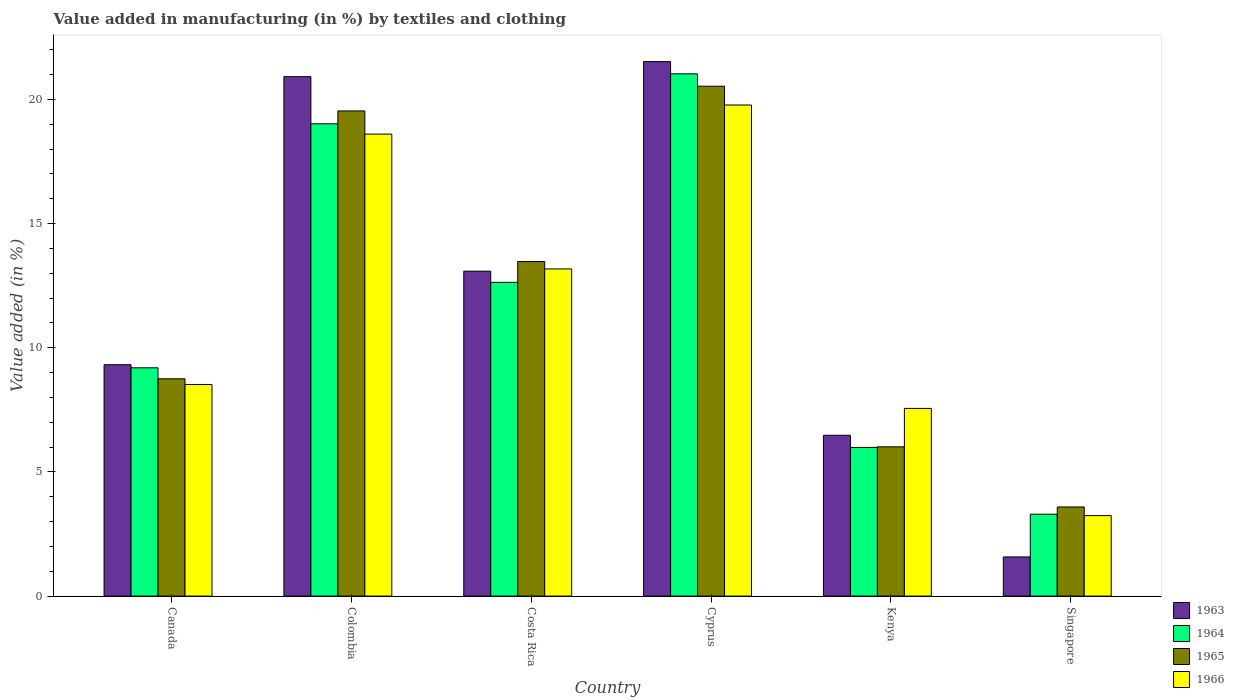Are the number of bars per tick equal to the number of legend labels?
Provide a short and direct response. Yes. How many bars are there on the 1st tick from the left?
Make the answer very short. 4. How many bars are there on the 3rd tick from the right?
Your answer should be compact. 4. What is the label of the 1st group of bars from the left?
Make the answer very short. Canada. What is the percentage of value added in manufacturing by textiles and clothing in 1965 in Singapore?
Your answer should be very brief. 3.59. Across all countries, what is the maximum percentage of value added in manufacturing by textiles and clothing in 1965?
Offer a terse response. 20.53. Across all countries, what is the minimum percentage of value added in manufacturing by textiles and clothing in 1966?
Offer a very short reply. 3.24. In which country was the percentage of value added in manufacturing by textiles and clothing in 1965 maximum?
Provide a succinct answer. Cyprus. In which country was the percentage of value added in manufacturing by textiles and clothing in 1963 minimum?
Your answer should be compact. Singapore. What is the total percentage of value added in manufacturing by textiles and clothing in 1966 in the graph?
Give a very brief answer. 70.87. What is the difference between the percentage of value added in manufacturing by textiles and clothing in 1966 in Costa Rica and that in Singapore?
Provide a succinct answer. 9.93. What is the difference between the percentage of value added in manufacturing by textiles and clothing in 1966 in Kenya and the percentage of value added in manufacturing by textiles and clothing in 1965 in Costa Rica?
Make the answer very short. -5.91. What is the average percentage of value added in manufacturing by textiles and clothing in 1963 per country?
Ensure brevity in your answer.  12.15. What is the difference between the percentage of value added in manufacturing by textiles and clothing of/in 1966 and percentage of value added in manufacturing by textiles and clothing of/in 1963 in Colombia?
Your answer should be compact. -2.31. In how many countries, is the percentage of value added in manufacturing by textiles and clothing in 1964 greater than 13 %?
Ensure brevity in your answer.  2. What is the ratio of the percentage of value added in manufacturing by textiles and clothing in 1964 in Colombia to that in Cyprus?
Offer a very short reply. 0.9. Is the difference between the percentage of value added in manufacturing by textiles and clothing in 1966 in Cyprus and Singapore greater than the difference between the percentage of value added in manufacturing by textiles and clothing in 1963 in Cyprus and Singapore?
Ensure brevity in your answer.  No. What is the difference between the highest and the second highest percentage of value added in manufacturing by textiles and clothing in 1965?
Keep it short and to the point. -0.99. What is the difference between the highest and the lowest percentage of value added in manufacturing by textiles and clothing in 1964?
Your response must be concise. 17.73. In how many countries, is the percentage of value added in manufacturing by textiles and clothing in 1965 greater than the average percentage of value added in manufacturing by textiles and clothing in 1965 taken over all countries?
Ensure brevity in your answer.  3. What does the 4th bar from the left in Canada represents?
Provide a succinct answer. 1966. What does the 3rd bar from the right in Kenya represents?
Ensure brevity in your answer.  1964. Are all the bars in the graph horizontal?
Your answer should be compact. No. What is the difference between two consecutive major ticks on the Y-axis?
Provide a short and direct response. 5. How many legend labels are there?
Your answer should be compact. 4. What is the title of the graph?
Your response must be concise. Value added in manufacturing (in %) by textiles and clothing. Does "1985" appear as one of the legend labels in the graph?
Offer a terse response. No. What is the label or title of the X-axis?
Keep it short and to the point. Country. What is the label or title of the Y-axis?
Offer a very short reply. Value added (in %). What is the Value added (in %) of 1963 in Canada?
Your answer should be very brief. 9.32. What is the Value added (in %) in 1964 in Canada?
Your answer should be very brief. 9.19. What is the Value added (in %) of 1965 in Canada?
Offer a very short reply. 8.75. What is the Value added (in %) of 1966 in Canada?
Provide a succinct answer. 8.52. What is the Value added (in %) in 1963 in Colombia?
Offer a terse response. 20.92. What is the Value added (in %) of 1964 in Colombia?
Ensure brevity in your answer.  19.02. What is the Value added (in %) of 1965 in Colombia?
Keep it short and to the point. 19.54. What is the Value added (in %) of 1966 in Colombia?
Ensure brevity in your answer.  18.6. What is the Value added (in %) of 1963 in Costa Rica?
Offer a very short reply. 13.08. What is the Value added (in %) of 1964 in Costa Rica?
Keep it short and to the point. 12.63. What is the Value added (in %) in 1965 in Costa Rica?
Your answer should be very brief. 13.47. What is the Value added (in %) of 1966 in Costa Rica?
Provide a succinct answer. 13.17. What is the Value added (in %) of 1963 in Cyprus?
Offer a very short reply. 21.52. What is the Value added (in %) of 1964 in Cyprus?
Your answer should be very brief. 21.03. What is the Value added (in %) in 1965 in Cyprus?
Offer a very short reply. 20.53. What is the Value added (in %) of 1966 in Cyprus?
Offer a terse response. 19.78. What is the Value added (in %) of 1963 in Kenya?
Keep it short and to the point. 6.48. What is the Value added (in %) in 1964 in Kenya?
Provide a succinct answer. 5.99. What is the Value added (in %) of 1965 in Kenya?
Your answer should be very brief. 6.01. What is the Value added (in %) in 1966 in Kenya?
Provide a short and direct response. 7.56. What is the Value added (in %) in 1963 in Singapore?
Your answer should be compact. 1.58. What is the Value added (in %) in 1964 in Singapore?
Your answer should be compact. 3.3. What is the Value added (in %) of 1965 in Singapore?
Your answer should be compact. 3.59. What is the Value added (in %) in 1966 in Singapore?
Keep it short and to the point. 3.24. Across all countries, what is the maximum Value added (in %) of 1963?
Keep it short and to the point. 21.52. Across all countries, what is the maximum Value added (in %) in 1964?
Give a very brief answer. 21.03. Across all countries, what is the maximum Value added (in %) in 1965?
Offer a terse response. 20.53. Across all countries, what is the maximum Value added (in %) in 1966?
Keep it short and to the point. 19.78. Across all countries, what is the minimum Value added (in %) in 1963?
Give a very brief answer. 1.58. Across all countries, what is the minimum Value added (in %) of 1964?
Your answer should be very brief. 3.3. Across all countries, what is the minimum Value added (in %) of 1965?
Offer a terse response. 3.59. Across all countries, what is the minimum Value added (in %) in 1966?
Offer a terse response. 3.24. What is the total Value added (in %) in 1963 in the graph?
Make the answer very short. 72.9. What is the total Value added (in %) in 1964 in the graph?
Offer a terse response. 71.16. What is the total Value added (in %) in 1965 in the graph?
Provide a short and direct response. 71.89. What is the total Value added (in %) in 1966 in the graph?
Your response must be concise. 70.87. What is the difference between the Value added (in %) in 1963 in Canada and that in Colombia?
Offer a terse response. -11.6. What is the difference between the Value added (in %) of 1964 in Canada and that in Colombia?
Offer a terse response. -9.82. What is the difference between the Value added (in %) of 1965 in Canada and that in Colombia?
Give a very brief answer. -10.79. What is the difference between the Value added (in %) in 1966 in Canada and that in Colombia?
Ensure brevity in your answer.  -10.08. What is the difference between the Value added (in %) of 1963 in Canada and that in Costa Rica?
Your answer should be very brief. -3.77. What is the difference between the Value added (in %) in 1964 in Canada and that in Costa Rica?
Keep it short and to the point. -3.44. What is the difference between the Value added (in %) of 1965 in Canada and that in Costa Rica?
Keep it short and to the point. -4.72. What is the difference between the Value added (in %) in 1966 in Canada and that in Costa Rica?
Offer a very short reply. -4.65. What is the difference between the Value added (in %) in 1963 in Canada and that in Cyprus?
Keep it short and to the point. -12.21. What is the difference between the Value added (in %) of 1964 in Canada and that in Cyprus?
Provide a succinct answer. -11.84. What is the difference between the Value added (in %) in 1965 in Canada and that in Cyprus?
Your answer should be very brief. -11.78. What is the difference between the Value added (in %) of 1966 in Canada and that in Cyprus?
Ensure brevity in your answer.  -11.25. What is the difference between the Value added (in %) of 1963 in Canada and that in Kenya?
Make the answer very short. 2.84. What is the difference between the Value added (in %) in 1964 in Canada and that in Kenya?
Offer a terse response. 3.21. What is the difference between the Value added (in %) in 1965 in Canada and that in Kenya?
Give a very brief answer. 2.74. What is the difference between the Value added (in %) in 1966 in Canada and that in Kenya?
Your answer should be compact. 0.96. What is the difference between the Value added (in %) of 1963 in Canada and that in Singapore?
Give a very brief answer. 7.74. What is the difference between the Value added (in %) of 1964 in Canada and that in Singapore?
Offer a terse response. 5.9. What is the difference between the Value added (in %) of 1965 in Canada and that in Singapore?
Your response must be concise. 5.16. What is the difference between the Value added (in %) of 1966 in Canada and that in Singapore?
Your answer should be compact. 5.28. What is the difference between the Value added (in %) in 1963 in Colombia and that in Costa Rica?
Provide a short and direct response. 7.83. What is the difference between the Value added (in %) of 1964 in Colombia and that in Costa Rica?
Keep it short and to the point. 6.38. What is the difference between the Value added (in %) in 1965 in Colombia and that in Costa Rica?
Offer a very short reply. 6.06. What is the difference between the Value added (in %) of 1966 in Colombia and that in Costa Rica?
Provide a succinct answer. 5.43. What is the difference between the Value added (in %) of 1963 in Colombia and that in Cyprus?
Your response must be concise. -0.61. What is the difference between the Value added (in %) in 1964 in Colombia and that in Cyprus?
Give a very brief answer. -2.01. What is the difference between the Value added (in %) of 1965 in Colombia and that in Cyprus?
Your response must be concise. -0.99. What is the difference between the Value added (in %) in 1966 in Colombia and that in Cyprus?
Offer a terse response. -1.17. What is the difference between the Value added (in %) of 1963 in Colombia and that in Kenya?
Offer a very short reply. 14.44. What is the difference between the Value added (in %) in 1964 in Colombia and that in Kenya?
Offer a terse response. 13.03. What is the difference between the Value added (in %) in 1965 in Colombia and that in Kenya?
Give a very brief answer. 13.53. What is the difference between the Value added (in %) of 1966 in Colombia and that in Kenya?
Offer a terse response. 11.05. What is the difference between the Value added (in %) of 1963 in Colombia and that in Singapore?
Your answer should be compact. 19.34. What is the difference between the Value added (in %) in 1964 in Colombia and that in Singapore?
Your answer should be very brief. 15.72. What is the difference between the Value added (in %) in 1965 in Colombia and that in Singapore?
Your answer should be compact. 15.95. What is the difference between the Value added (in %) of 1966 in Colombia and that in Singapore?
Give a very brief answer. 15.36. What is the difference between the Value added (in %) in 1963 in Costa Rica and that in Cyprus?
Provide a succinct answer. -8.44. What is the difference between the Value added (in %) in 1964 in Costa Rica and that in Cyprus?
Offer a very short reply. -8.4. What is the difference between the Value added (in %) of 1965 in Costa Rica and that in Cyprus?
Your answer should be very brief. -7.06. What is the difference between the Value added (in %) in 1966 in Costa Rica and that in Cyprus?
Ensure brevity in your answer.  -6.6. What is the difference between the Value added (in %) in 1963 in Costa Rica and that in Kenya?
Provide a short and direct response. 6.61. What is the difference between the Value added (in %) in 1964 in Costa Rica and that in Kenya?
Your answer should be compact. 6.65. What is the difference between the Value added (in %) of 1965 in Costa Rica and that in Kenya?
Offer a terse response. 7.46. What is the difference between the Value added (in %) of 1966 in Costa Rica and that in Kenya?
Keep it short and to the point. 5.62. What is the difference between the Value added (in %) of 1963 in Costa Rica and that in Singapore?
Provide a succinct answer. 11.51. What is the difference between the Value added (in %) in 1964 in Costa Rica and that in Singapore?
Your answer should be very brief. 9.34. What is the difference between the Value added (in %) of 1965 in Costa Rica and that in Singapore?
Keep it short and to the point. 9.88. What is the difference between the Value added (in %) in 1966 in Costa Rica and that in Singapore?
Provide a short and direct response. 9.93. What is the difference between the Value added (in %) of 1963 in Cyprus and that in Kenya?
Provide a short and direct response. 15.05. What is the difference between the Value added (in %) of 1964 in Cyprus and that in Kenya?
Offer a very short reply. 15.04. What is the difference between the Value added (in %) in 1965 in Cyprus and that in Kenya?
Ensure brevity in your answer.  14.52. What is the difference between the Value added (in %) in 1966 in Cyprus and that in Kenya?
Your answer should be very brief. 12.22. What is the difference between the Value added (in %) of 1963 in Cyprus and that in Singapore?
Ensure brevity in your answer.  19.95. What is the difference between the Value added (in %) of 1964 in Cyprus and that in Singapore?
Keep it short and to the point. 17.73. What is the difference between the Value added (in %) of 1965 in Cyprus and that in Singapore?
Your answer should be very brief. 16.94. What is the difference between the Value added (in %) in 1966 in Cyprus and that in Singapore?
Your answer should be very brief. 16.53. What is the difference between the Value added (in %) of 1963 in Kenya and that in Singapore?
Your answer should be very brief. 4.9. What is the difference between the Value added (in %) of 1964 in Kenya and that in Singapore?
Keep it short and to the point. 2.69. What is the difference between the Value added (in %) in 1965 in Kenya and that in Singapore?
Offer a terse response. 2.42. What is the difference between the Value added (in %) in 1966 in Kenya and that in Singapore?
Ensure brevity in your answer.  4.32. What is the difference between the Value added (in %) in 1963 in Canada and the Value added (in %) in 1964 in Colombia?
Keep it short and to the point. -9.7. What is the difference between the Value added (in %) in 1963 in Canada and the Value added (in %) in 1965 in Colombia?
Provide a succinct answer. -10.22. What is the difference between the Value added (in %) of 1963 in Canada and the Value added (in %) of 1966 in Colombia?
Offer a terse response. -9.29. What is the difference between the Value added (in %) in 1964 in Canada and the Value added (in %) in 1965 in Colombia?
Keep it short and to the point. -10.34. What is the difference between the Value added (in %) of 1964 in Canada and the Value added (in %) of 1966 in Colombia?
Keep it short and to the point. -9.41. What is the difference between the Value added (in %) in 1965 in Canada and the Value added (in %) in 1966 in Colombia?
Keep it short and to the point. -9.85. What is the difference between the Value added (in %) in 1963 in Canada and the Value added (in %) in 1964 in Costa Rica?
Your response must be concise. -3.32. What is the difference between the Value added (in %) of 1963 in Canada and the Value added (in %) of 1965 in Costa Rica?
Offer a very short reply. -4.16. What is the difference between the Value added (in %) in 1963 in Canada and the Value added (in %) in 1966 in Costa Rica?
Provide a short and direct response. -3.86. What is the difference between the Value added (in %) of 1964 in Canada and the Value added (in %) of 1965 in Costa Rica?
Provide a short and direct response. -4.28. What is the difference between the Value added (in %) of 1964 in Canada and the Value added (in %) of 1966 in Costa Rica?
Make the answer very short. -3.98. What is the difference between the Value added (in %) of 1965 in Canada and the Value added (in %) of 1966 in Costa Rica?
Your answer should be very brief. -4.42. What is the difference between the Value added (in %) in 1963 in Canada and the Value added (in %) in 1964 in Cyprus?
Offer a terse response. -11.71. What is the difference between the Value added (in %) of 1963 in Canada and the Value added (in %) of 1965 in Cyprus?
Your answer should be compact. -11.21. What is the difference between the Value added (in %) in 1963 in Canada and the Value added (in %) in 1966 in Cyprus?
Your answer should be very brief. -10.46. What is the difference between the Value added (in %) in 1964 in Canada and the Value added (in %) in 1965 in Cyprus?
Make the answer very short. -11.34. What is the difference between the Value added (in %) in 1964 in Canada and the Value added (in %) in 1966 in Cyprus?
Offer a very short reply. -10.58. What is the difference between the Value added (in %) of 1965 in Canada and the Value added (in %) of 1966 in Cyprus?
Provide a short and direct response. -11.02. What is the difference between the Value added (in %) of 1963 in Canada and the Value added (in %) of 1964 in Kenya?
Keep it short and to the point. 3.33. What is the difference between the Value added (in %) of 1963 in Canada and the Value added (in %) of 1965 in Kenya?
Keep it short and to the point. 3.31. What is the difference between the Value added (in %) of 1963 in Canada and the Value added (in %) of 1966 in Kenya?
Keep it short and to the point. 1.76. What is the difference between the Value added (in %) of 1964 in Canada and the Value added (in %) of 1965 in Kenya?
Your answer should be very brief. 3.18. What is the difference between the Value added (in %) in 1964 in Canada and the Value added (in %) in 1966 in Kenya?
Your response must be concise. 1.64. What is the difference between the Value added (in %) of 1965 in Canada and the Value added (in %) of 1966 in Kenya?
Your answer should be very brief. 1.19. What is the difference between the Value added (in %) of 1963 in Canada and the Value added (in %) of 1964 in Singapore?
Your response must be concise. 6.02. What is the difference between the Value added (in %) in 1963 in Canada and the Value added (in %) in 1965 in Singapore?
Make the answer very short. 5.73. What is the difference between the Value added (in %) of 1963 in Canada and the Value added (in %) of 1966 in Singapore?
Your answer should be very brief. 6.08. What is the difference between the Value added (in %) in 1964 in Canada and the Value added (in %) in 1965 in Singapore?
Your answer should be very brief. 5.6. What is the difference between the Value added (in %) in 1964 in Canada and the Value added (in %) in 1966 in Singapore?
Give a very brief answer. 5.95. What is the difference between the Value added (in %) in 1965 in Canada and the Value added (in %) in 1966 in Singapore?
Make the answer very short. 5.51. What is the difference between the Value added (in %) of 1963 in Colombia and the Value added (in %) of 1964 in Costa Rica?
Your response must be concise. 8.28. What is the difference between the Value added (in %) in 1963 in Colombia and the Value added (in %) in 1965 in Costa Rica?
Give a very brief answer. 7.44. What is the difference between the Value added (in %) in 1963 in Colombia and the Value added (in %) in 1966 in Costa Rica?
Offer a terse response. 7.74. What is the difference between the Value added (in %) of 1964 in Colombia and the Value added (in %) of 1965 in Costa Rica?
Offer a very short reply. 5.55. What is the difference between the Value added (in %) in 1964 in Colombia and the Value added (in %) in 1966 in Costa Rica?
Provide a succinct answer. 5.84. What is the difference between the Value added (in %) of 1965 in Colombia and the Value added (in %) of 1966 in Costa Rica?
Your answer should be very brief. 6.36. What is the difference between the Value added (in %) in 1963 in Colombia and the Value added (in %) in 1964 in Cyprus?
Your response must be concise. -0.11. What is the difference between the Value added (in %) in 1963 in Colombia and the Value added (in %) in 1965 in Cyprus?
Give a very brief answer. 0.39. What is the difference between the Value added (in %) in 1963 in Colombia and the Value added (in %) in 1966 in Cyprus?
Provide a short and direct response. 1.14. What is the difference between the Value added (in %) in 1964 in Colombia and the Value added (in %) in 1965 in Cyprus?
Your answer should be compact. -1.51. What is the difference between the Value added (in %) of 1964 in Colombia and the Value added (in %) of 1966 in Cyprus?
Your response must be concise. -0.76. What is the difference between the Value added (in %) of 1965 in Colombia and the Value added (in %) of 1966 in Cyprus?
Your answer should be compact. -0.24. What is the difference between the Value added (in %) in 1963 in Colombia and the Value added (in %) in 1964 in Kenya?
Ensure brevity in your answer.  14.93. What is the difference between the Value added (in %) of 1963 in Colombia and the Value added (in %) of 1965 in Kenya?
Offer a terse response. 14.91. What is the difference between the Value added (in %) in 1963 in Colombia and the Value added (in %) in 1966 in Kenya?
Ensure brevity in your answer.  13.36. What is the difference between the Value added (in %) of 1964 in Colombia and the Value added (in %) of 1965 in Kenya?
Ensure brevity in your answer.  13.01. What is the difference between the Value added (in %) of 1964 in Colombia and the Value added (in %) of 1966 in Kenya?
Your answer should be very brief. 11.46. What is the difference between the Value added (in %) in 1965 in Colombia and the Value added (in %) in 1966 in Kenya?
Provide a succinct answer. 11.98. What is the difference between the Value added (in %) of 1963 in Colombia and the Value added (in %) of 1964 in Singapore?
Make the answer very short. 17.62. What is the difference between the Value added (in %) in 1963 in Colombia and the Value added (in %) in 1965 in Singapore?
Ensure brevity in your answer.  17.33. What is the difference between the Value added (in %) of 1963 in Colombia and the Value added (in %) of 1966 in Singapore?
Provide a succinct answer. 17.68. What is the difference between the Value added (in %) in 1964 in Colombia and the Value added (in %) in 1965 in Singapore?
Provide a succinct answer. 15.43. What is the difference between the Value added (in %) in 1964 in Colombia and the Value added (in %) in 1966 in Singapore?
Offer a very short reply. 15.78. What is the difference between the Value added (in %) of 1965 in Colombia and the Value added (in %) of 1966 in Singapore?
Give a very brief answer. 16.3. What is the difference between the Value added (in %) of 1963 in Costa Rica and the Value added (in %) of 1964 in Cyprus?
Your response must be concise. -7.95. What is the difference between the Value added (in %) of 1963 in Costa Rica and the Value added (in %) of 1965 in Cyprus?
Offer a very short reply. -7.45. What is the difference between the Value added (in %) in 1963 in Costa Rica and the Value added (in %) in 1966 in Cyprus?
Your answer should be very brief. -6.69. What is the difference between the Value added (in %) in 1964 in Costa Rica and the Value added (in %) in 1965 in Cyprus?
Offer a very short reply. -7.9. What is the difference between the Value added (in %) in 1964 in Costa Rica and the Value added (in %) in 1966 in Cyprus?
Keep it short and to the point. -7.14. What is the difference between the Value added (in %) of 1965 in Costa Rica and the Value added (in %) of 1966 in Cyprus?
Give a very brief answer. -6.3. What is the difference between the Value added (in %) of 1963 in Costa Rica and the Value added (in %) of 1964 in Kenya?
Ensure brevity in your answer.  7.1. What is the difference between the Value added (in %) of 1963 in Costa Rica and the Value added (in %) of 1965 in Kenya?
Offer a terse response. 7.07. What is the difference between the Value added (in %) in 1963 in Costa Rica and the Value added (in %) in 1966 in Kenya?
Make the answer very short. 5.53. What is the difference between the Value added (in %) of 1964 in Costa Rica and the Value added (in %) of 1965 in Kenya?
Provide a short and direct response. 6.62. What is the difference between the Value added (in %) of 1964 in Costa Rica and the Value added (in %) of 1966 in Kenya?
Ensure brevity in your answer.  5.08. What is the difference between the Value added (in %) of 1965 in Costa Rica and the Value added (in %) of 1966 in Kenya?
Provide a succinct answer. 5.91. What is the difference between the Value added (in %) in 1963 in Costa Rica and the Value added (in %) in 1964 in Singapore?
Make the answer very short. 9.79. What is the difference between the Value added (in %) in 1963 in Costa Rica and the Value added (in %) in 1965 in Singapore?
Offer a very short reply. 9.5. What is the difference between the Value added (in %) of 1963 in Costa Rica and the Value added (in %) of 1966 in Singapore?
Your answer should be very brief. 9.84. What is the difference between the Value added (in %) in 1964 in Costa Rica and the Value added (in %) in 1965 in Singapore?
Ensure brevity in your answer.  9.04. What is the difference between the Value added (in %) in 1964 in Costa Rica and the Value added (in %) in 1966 in Singapore?
Your answer should be very brief. 9.39. What is the difference between the Value added (in %) of 1965 in Costa Rica and the Value added (in %) of 1966 in Singapore?
Ensure brevity in your answer.  10.23. What is the difference between the Value added (in %) in 1963 in Cyprus and the Value added (in %) in 1964 in Kenya?
Provide a short and direct response. 15.54. What is the difference between the Value added (in %) in 1963 in Cyprus and the Value added (in %) in 1965 in Kenya?
Make the answer very short. 15.51. What is the difference between the Value added (in %) of 1963 in Cyprus and the Value added (in %) of 1966 in Kenya?
Keep it short and to the point. 13.97. What is the difference between the Value added (in %) of 1964 in Cyprus and the Value added (in %) of 1965 in Kenya?
Offer a terse response. 15.02. What is the difference between the Value added (in %) of 1964 in Cyprus and the Value added (in %) of 1966 in Kenya?
Keep it short and to the point. 13.47. What is the difference between the Value added (in %) in 1965 in Cyprus and the Value added (in %) in 1966 in Kenya?
Give a very brief answer. 12.97. What is the difference between the Value added (in %) of 1963 in Cyprus and the Value added (in %) of 1964 in Singapore?
Offer a very short reply. 18.23. What is the difference between the Value added (in %) in 1963 in Cyprus and the Value added (in %) in 1965 in Singapore?
Keep it short and to the point. 17.93. What is the difference between the Value added (in %) in 1963 in Cyprus and the Value added (in %) in 1966 in Singapore?
Offer a terse response. 18.28. What is the difference between the Value added (in %) of 1964 in Cyprus and the Value added (in %) of 1965 in Singapore?
Make the answer very short. 17.44. What is the difference between the Value added (in %) of 1964 in Cyprus and the Value added (in %) of 1966 in Singapore?
Your answer should be compact. 17.79. What is the difference between the Value added (in %) of 1965 in Cyprus and the Value added (in %) of 1966 in Singapore?
Provide a short and direct response. 17.29. What is the difference between the Value added (in %) of 1963 in Kenya and the Value added (in %) of 1964 in Singapore?
Offer a terse response. 3.18. What is the difference between the Value added (in %) of 1963 in Kenya and the Value added (in %) of 1965 in Singapore?
Offer a terse response. 2.89. What is the difference between the Value added (in %) in 1963 in Kenya and the Value added (in %) in 1966 in Singapore?
Offer a very short reply. 3.24. What is the difference between the Value added (in %) in 1964 in Kenya and the Value added (in %) in 1965 in Singapore?
Your answer should be very brief. 2.4. What is the difference between the Value added (in %) of 1964 in Kenya and the Value added (in %) of 1966 in Singapore?
Your response must be concise. 2.75. What is the difference between the Value added (in %) in 1965 in Kenya and the Value added (in %) in 1966 in Singapore?
Keep it short and to the point. 2.77. What is the average Value added (in %) in 1963 per country?
Provide a succinct answer. 12.15. What is the average Value added (in %) of 1964 per country?
Ensure brevity in your answer.  11.86. What is the average Value added (in %) in 1965 per country?
Make the answer very short. 11.98. What is the average Value added (in %) of 1966 per country?
Provide a succinct answer. 11.81. What is the difference between the Value added (in %) of 1963 and Value added (in %) of 1964 in Canada?
Provide a succinct answer. 0.12. What is the difference between the Value added (in %) in 1963 and Value added (in %) in 1965 in Canada?
Offer a very short reply. 0.57. What is the difference between the Value added (in %) of 1963 and Value added (in %) of 1966 in Canada?
Give a very brief answer. 0.8. What is the difference between the Value added (in %) of 1964 and Value added (in %) of 1965 in Canada?
Provide a succinct answer. 0.44. What is the difference between the Value added (in %) in 1964 and Value added (in %) in 1966 in Canada?
Your answer should be very brief. 0.67. What is the difference between the Value added (in %) of 1965 and Value added (in %) of 1966 in Canada?
Give a very brief answer. 0.23. What is the difference between the Value added (in %) of 1963 and Value added (in %) of 1964 in Colombia?
Keep it short and to the point. 1.9. What is the difference between the Value added (in %) of 1963 and Value added (in %) of 1965 in Colombia?
Offer a terse response. 1.38. What is the difference between the Value added (in %) in 1963 and Value added (in %) in 1966 in Colombia?
Provide a short and direct response. 2.31. What is the difference between the Value added (in %) in 1964 and Value added (in %) in 1965 in Colombia?
Offer a very short reply. -0.52. What is the difference between the Value added (in %) in 1964 and Value added (in %) in 1966 in Colombia?
Your answer should be very brief. 0.41. What is the difference between the Value added (in %) in 1965 and Value added (in %) in 1966 in Colombia?
Offer a terse response. 0.93. What is the difference between the Value added (in %) of 1963 and Value added (in %) of 1964 in Costa Rica?
Your response must be concise. 0.45. What is the difference between the Value added (in %) in 1963 and Value added (in %) in 1965 in Costa Rica?
Offer a very short reply. -0.39. What is the difference between the Value added (in %) of 1963 and Value added (in %) of 1966 in Costa Rica?
Keep it short and to the point. -0.09. What is the difference between the Value added (in %) in 1964 and Value added (in %) in 1965 in Costa Rica?
Your response must be concise. -0.84. What is the difference between the Value added (in %) of 1964 and Value added (in %) of 1966 in Costa Rica?
Your answer should be compact. -0.54. What is the difference between the Value added (in %) of 1965 and Value added (in %) of 1966 in Costa Rica?
Make the answer very short. 0.3. What is the difference between the Value added (in %) of 1963 and Value added (in %) of 1964 in Cyprus?
Ensure brevity in your answer.  0.49. What is the difference between the Value added (in %) of 1963 and Value added (in %) of 1965 in Cyprus?
Provide a succinct answer. 0.99. What is the difference between the Value added (in %) of 1963 and Value added (in %) of 1966 in Cyprus?
Your response must be concise. 1.75. What is the difference between the Value added (in %) of 1964 and Value added (in %) of 1965 in Cyprus?
Offer a very short reply. 0.5. What is the difference between the Value added (in %) of 1964 and Value added (in %) of 1966 in Cyprus?
Give a very brief answer. 1.25. What is the difference between the Value added (in %) in 1965 and Value added (in %) in 1966 in Cyprus?
Your response must be concise. 0.76. What is the difference between the Value added (in %) of 1963 and Value added (in %) of 1964 in Kenya?
Give a very brief answer. 0.49. What is the difference between the Value added (in %) of 1963 and Value added (in %) of 1965 in Kenya?
Offer a terse response. 0.47. What is the difference between the Value added (in %) in 1963 and Value added (in %) in 1966 in Kenya?
Your answer should be very brief. -1.08. What is the difference between the Value added (in %) in 1964 and Value added (in %) in 1965 in Kenya?
Provide a succinct answer. -0.02. What is the difference between the Value added (in %) in 1964 and Value added (in %) in 1966 in Kenya?
Provide a succinct answer. -1.57. What is the difference between the Value added (in %) of 1965 and Value added (in %) of 1966 in Kenya?
Make the answer very short. -1.55. What is the difference between the Value added (in %) of 1963 and Value added (in %) of 1964 in Singapore?
Your answer should be very brief. -1.72. What is the difference between the Value added (in %) in 1963 and Value added (in %) in 1965 in Singapore?
Your answer should be compact. -2.01. What is the difference between the Value added (in %) of 1963 and Value added (in %) of 1966 in Singapore?
Your answer should be compact. -1.66. What is the difference between the Value added (in %) in 1964 and Value added (in %) in 1965 in Singapore?
Your answer should be very brief. -0.29. What is the difference between the Value added (in %) of 1964 and Value added (in %) of 1966 in Singapore?
Offer a very short reply. 0.06. What is the difference between the Value added (in %) in 1965 and Value added (in %) in 1966 in Singapore?
Give a very brief answer. 0.35. What is the ratio of the Value added (in %) in 1963 in Canada to that in Colombia?
Your answer should be compact. 0.45. What is the ratio of the Value added (in %) of 1964 in Canada to that in Colombia?
Your answer should be very brief. 0.48. What is the ratio of the Value added (in %) of 1965 in Canada to that in Colombia?
Your answer should be compact. 0.45. What is the ratio of the Value added (in %) in 1966 in Canada to that in Colombia?
Your answer should be very brief. 0.46. What is the ratio of the Value added (in %) in 1963 in Canada to that in Costa Rica?
Ensure brevity in your answer.  0.71. What is the ratio of the Value added (in %) of 1964 in Canada to that in Costa Rica?
Your answer should be compact. 0.73. What is the ratio of the Value added (in %) in 1965 in Canada to that in Costa Rica?
Your answer should be very brief. 0.65. What is the ratio of the Value added (in %) of 1966 in Canada to that in Costa Rica?
Offer a terse response. 0.65. What is the ratio of the Value added (in %) in 1963 in Canada to that in Cyprus?
Give a very brief answer. 0.43. What is the ratio of the Value added (in %) of 1964 in Canada to that in Cyprus?
Provide a short and direct response. 0.44. What is the ratio of the Value added (in %) in 1965 in Canada to that in Cyprus?
Your answer should be very brief. 0.43. What is the ratio of the Value added (in %) of 1966 in Canada to that in Cyprus?
Provide a succinct answer. 0.43. What is the ratio of the Value added (in %) in 1963 in Canada to that in Kenya?
Offer a terse response. 1.44. What is the ratio of the Value added (in %) of 1964 in Canada to that in Kenya?
Provide a short and direct response. 1.54. What is the ratio of the Value added (in %) of 1965 in Canada to that in Kenya?
Provide a succinct answer. 1.46. What is the ratio of the Value added (in %) of 1966 in Canada to that in Kenya?
Keep it short and to the point. 1.13. What is the ratio of the Value added (in %) in 1963 in Canada to that in Singapore?
Provide a succinct answer. 5.91. What is the ratio of the Value added (in %) of 1964 in Canada to that in Singapore?
Offer a very short reply. 2.79. What is the ratio of the Value added (in %) of 1965 in Canada to that in Singapore?
Your answer should be very brief. 2.44. What is the ratio of the Value added (in %) of 1966 in Canada to that in Singapore?
Give a very brief answer. 2.63. What is the ratio of the Value added (in %) of 1963 in Colombia to that in Costa Rica?
Make the answer very short. 1.6. What is the ratio of the Value added (in %) of 1964 in Colombia to that in Costa Rica?
Offer a terse response. 1.51. What is the ratio of the Value added (in %) in 1965 in Colombia to that in Costa Rica?
Your answer should be compact. 1.45. What is the ratio of the Value added (in %) in 1966 in Colombia to that in Costa Rica?
Keep it short and to the point. 1.41. What is the ratio of the Value added (in %) of 1963 in Colombia to that in Cyprus?
Offer a very short reply. 0.97. What is the ratio of the Value added (in %) in 1964 in Colombia to that in Cyprus?
Your answer should be very brief. 0.9. What is the ratio of the Value added (in %) in 1965 in Colombia to that in Cyprus?
Ensure brevity in your answer.  0.95. What is the ratio of the Value added (in %) of 1966 in Colombia to that in Cyprus?
Offer a terse response. 0.94. What is the ratio of the Value added (in %) of 1963 in Colombia to that in Kenya?
Offer a terse response. 3.23. What is the ratio of the Value added (in %) of 1964 in Colombia to that in Kenya?
Your answer should be very brief. 3.18. What is the ratio of the Value added (in %) of 1966 in Colombia to that in Kenya?
Offer a very short reply. 2.46. What is the ratio of the Value added (in %) of 1963 in Colombia to that in Singapore?
Your answer should be very brief. 13.26. What is the ratio of the Value added (in %) in 1964 in Colombia to that in Singapore?
Offer a terse response. 5.77. What is the ratio of the Value added (in %) in 1965 in Colombia to that in Singapore?
Ensure brevity in your answer.  5.44. What is the ratio of the Value added (in %) of 1966 in Colombia to that in Singapore?
Provide a succinct answer. 5.74. What is the ratio of the Value added (in %) in 1963 in Costa Rica to that in Cyprus?
Keep it short and to the point. 0.61. What is the ratio of the Value added (in %) in 1964 in Costa Rica to that in Cyprus?
Provide a succinct answer. 0.6. What is the ratio of the Value added (in %) in 1965 in Costa Rica to that in Cyprus?
Your answer should be compact. 0.66. What is the ratio of the Value added (in %) of 1966 in Costa Rica to that in Cyprus?
Provide a succinct answer. 0.67. What is the ratio of the Value added (in %) in 1963 in Costa Rica to that in Kenya?
Offer a very short reply. 2.02. What is the ratio of the Value added (in %) in 1964 in Costa Rica to that in Kenya?
Your answer should be very brief. 2.11. What is the ratio of the Value added (in %) in 1965 in Costa Rica to that in Kenya?
Offer a terse response. 2.24. What is the ratio of the Value added (in %) of 1966 in Costa Rica to that in Kenya?
Offer a very short reply. 1.74. What is the ratio of the Value added (in %) in 1963 in Costa Rica to that in Singapore?
Your answer should be very brief. 8.3. What is the ratio of the Value added (in %) of 1964 in Costa Rica to that in Singapore?
Your response must be concise. 3.83. What is the ratio of the Value added (in %) of 1965 in Costa Rica to that in Singapore?
Keep it short and to the point. 3.75. What is the ratio of the Value added (in %) in 1966 in Costa Rica to that in Singapore?
Provide a succinct answer. 4.06. What is the ratio of the Value added (in %) of 1963 in Cyprus to that in Kenya?
Your answer should be compact. 3.32. What is the ratio of the Value added (in %) of 1964 in Cyprus to that in Kenya?
Offer a terse response. 3.51. What is the ratio of the Value added (in %) in 1965 in Cyprus to that in Kenya?
Make the answer very short. 3.42. What is the ratio of the Value added (in %) in 1966 in Cyprus to that in Kenya?
Your answer should be compact. 2.62. What is the ratio of the Value added (in %) of 1963 in Cyprus to that in Singapore?
Provide a short and direct response. 13.65. What is the ratio of the Value added (in %) of 1964 in Cyprus to that in Singapore?
Give a very brief answer. 6.38. What is the ratio of the Value added (in %) of 1965 in Cyprus to that in Singapore?
Your answer should be very brief. 5.72. What is the ratio of the Value added (in %) of 1966 in Cyprus to that in Singapore?
Give a very brief answer. 6.1. What is the ratio of the Value added (in %) of 1963 in Kenya to that in Singapore?
Ensure brevity in your answer.  4.11. What is the ratio of the Value added (in %) in 1964 in Kenya to that in Singapore?
Give a very brief answer. 1.82. What is the ratio of the Value added (in %) in 1965 in Kenya to that in Singapore?
Offer a very short reply. 1.67. What is the ratio of the Value added (in %) of 1966 in Kenya to that in Singapore?
Ensure brevity in your answer.  2.33. What is the difference between the highest and the second highest Value added (in %) of 1963?
Provide a succinct answer. 0.61. What is the difference between the highest and the second highest Value added (in %) in 1964?
Provide a short and direct response. 2.01. What is the difference between the highest and the second highest Value added (in %) of 1965?
Keep it short and to the point. 0.99. What is the difference between the highest and the second highest Value added (in %) in 1966?
Your response must be concise. 1.17. What is the difference between the highest and the lowest Value added (in %) of 1963?
Your answer should be compact. 19.95. What is the difference between the highest and the lowest Value added (in %) of 1964?
Keep it short and to the point. 17.73. What is the difference between the highest and the lowest Value added (in %) in 1965?
Your answer should be very brief. 16.94. What is the difference between the highest and the lowest Value added (in %) in 1966?
Ensure brevity in your answer.  16.53. 